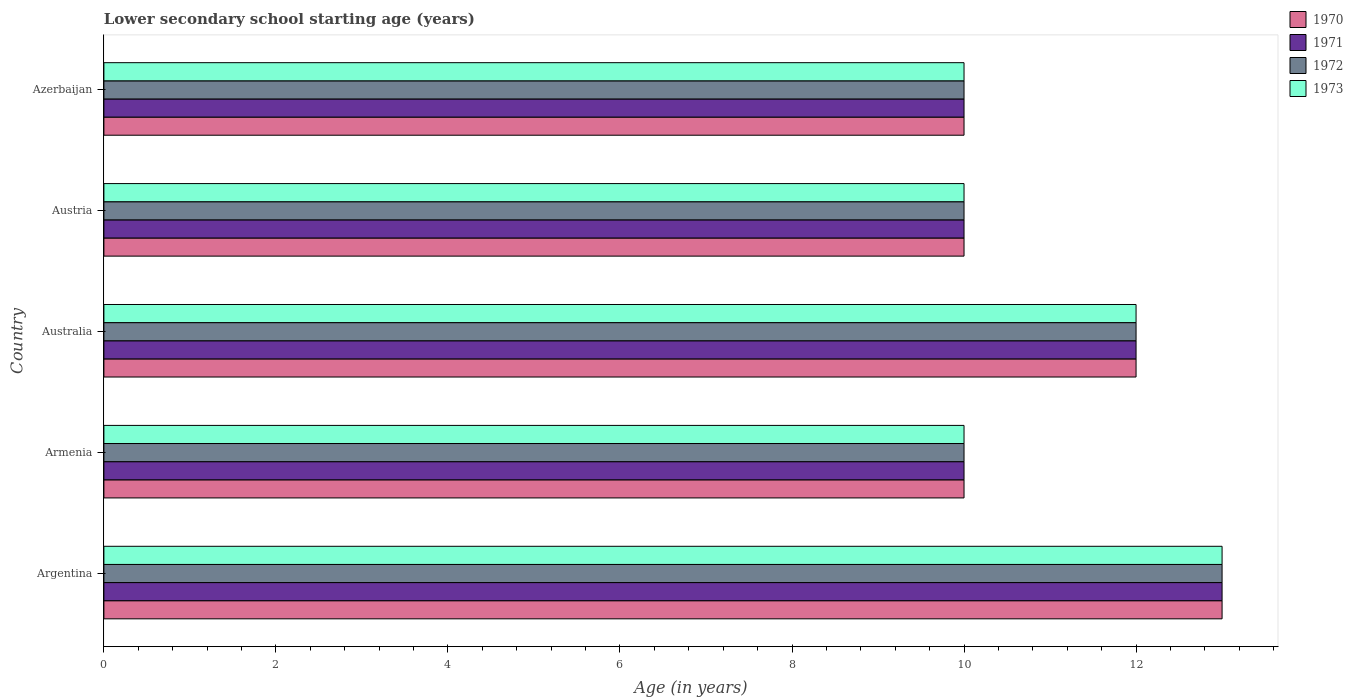How many bars are there on the 3rd tick from the top?
Your answer should be very brief. 4. How many bars are there on the 2nd tick from the bottom?
Offer a terse response. 4. What is the label of the 1st group of bars from the top?
Give a very brief answer. Azerbaijan. In how many cases, is the number of bars for a given country not equal to the number of legend labels?
Provide a short and direct response. 0. Across all countries, what is the maximum lower secondary school starting age of children in 1971?
Provide a succinct answer. 13. Across all countries, what is the minimum lower secondary school starting age of children in 1973?
Your answer should be compact. 10. In which country was the lower secondary school starting age of children in 1972 maximum?
Your answer should be compact. Argentina. In which country was the lower secondary school starting age of children in 1971 minimum?
Your answer should be compact. Armenia. What is the total lower secondary school starting age of children in 1970 in the graph?
Your response must be concise. 55. What is the difference between the lower secondary school starting age of children in 1971 in Argentina and that in Azerbaijan?
Offer a terse response. 3. What is the average lower secondary school starting age of children in 1970 per country?
Provide a succinct answer. 11. Is the lower secondary school starting age of children in 1970 in Argentina less than that in Armenia?
Provide a short and direct response. No. Is the difference between the lower secondary school starting age of children in 1973 in Armenia and Azerbaijan greater than the difference between the lower secondary school starting age of children in 1970 in Armenia and Azerbaijan?
Ensure brevity in your answer.  No. What is the difference between the highest and the second highest lower secondary school starting age of children in 1973?
Keep it short and to the point. 1. What is the difference between the highest and the lowest lower secondary school starting age of children in 1972?
Your response must be concise. 3. Is the sum of the lower secondary school starting age of children in 1971 in Armenia and Austria greater than the maximum lower secondary school starting age of children in 1972 across all countries?
Give a very brief answer. Yes. Is it the case that in every country, the sum of the lower secondary school starting age of children in 1972 and lower secondary school starting age of children in 1973 is greater than the sum of lower secondary school starting age of children in 1971 and lower secondary school starting age of children in 1970?
Your response must be concise. No. What does the 3rd bar from the top in Austria represents?
Keep it short and to the point. 1971. How many bars are there?
Your response must be concise. 20. Are all the bars in the graph horizontal?
Offer a terse response. Yes. How many countries are there in the graph?
Keep it short and to the point. 5. Where does the legend appear in the graph?
Provide a short and direct response. Top right. What is the title of the graph?
Your answer should be very brief. Lower secondary school starting age (years). What is the label or title of the X-axis?
Give a very brief answer. Age (in years). What is the Age (in years) in 1973 in Argentina?
Offer a terse response. 13. What is the Age (in years) of 1972 in Australia?
Your response must be concise. 12. What is the Age (in years) of 1970 in Austria?
Your answer should be very brief. 10. What is the Age (in years) in 1971 in Austria?
Provide a succinct answer. 10. What is the Age (in years) in 1970 in Azerbaijan?
Your answer should be compact. 10. What is the Age (in years) of 1973 in Azerbaijan?
Your answer should be very brief. 10. Across all countries, what is the maximum Age (in years) in 1971?
Your answer should be very brief. 13. Across all countries, what is the maximum Age (in years) in 1972?
Provide a succinct answer. 13. Across all countries, what is the minimum Age (in years) in 1970?
Offer a terse response. 10. What is the total Age (in years) in 1973 in the graph?
Your response must be concise. 55. What is the difference between the Age (in years) in 1971 in Argentina and that in Australia?
Ensure brevity in your answer.  1. What is the difference between the Age (in years) of 1973 in Argentina and that in Australia?
Offer a very short reply. 1. What is the difference between the Age (in years) of 1971 in Argentina and that in Austria?
Ensure brevity in your answer.  3. What is the difference between the Age (in years) in 1972 in Argentina and that in Austria?
Provide a succinct answer. 3. What is the difference between the Age (in years) of 1971 in Argentina and that in Azerbaijan?
Offer a very short reply. 3. What is the difference between the Age (in years) in 1973 in Armenia and that in Australia?
Keep it short and to the point. -2. What is the difference between the Age (in years) of 1970 in Armenia and that in Austria?
Make the answer very short. 0. What is the difference between the Age (in years) in 1971 in Armenia and that in Austria?
Offer a terse response. 0. What is the difference between the Age (in years) of 1972 in Armenia and that in Austria?
Provide a succinct answer. 0. What is the difference between the Age (in years) of 1971 in Armenia and that in Azerbaijan?
Your answer should be very brief. 0. What is the difference between the Age (in years) in 1972 in Armenia and that in Azerbaijan?
Make the answer very short. 0. What is the difference between the Age (in years) in 1973 in Armenia and that in Azerbaijan?
Keep it short and to the point. 0. What is the difference between the Age (in years) in 1971 in Australia and that in Austria?
Offer a very short reply. 2. What is the difference between the Age (in years) of 1971 in Australia and that in Azerbaijan?
Offer a terse response. 2. What is the difference between the Age (in years) in 1972 in Australia and that in Azerbaijan?
Offer a terse response. 2. What is the difference between the Age (in years) of 1970 in Austria and that in Azerbaijan?
Keep it short and to the point. 0. What is the difference between the Age (in years) in 1971 in Austria and that in Azerbaijan?
Your response must be concise. 0. What is the difference between the Age (in years) in 1972 in Austria and that in Azerbaijan?
Your answer should be very brief. 0. What is the difference between the Age (in years) of 1970 in Argentina and the Age (in years) of 1972 in Armenia?
Offer a terse response. 3. What is the difference between the Age (in years) of 1971 in Argentina and the Age (in years) of 1972 in Armenia?
Offer a terse response. 3. What is the difference between the Age (in years) in 1971 in Argentina and the Age (in years) in 1973 in Armenia?
Give a very brief answer. 3. What is the difference between the Age (in years) of 1970 in Argentina and the Age (in years) of 1971 in Australia?
Keep it short and to the point. 1. What is the difference between the Age (in years) in 1970 in Argentina and the Age (in years) in 1972 in Australia?
Your answer should be very brief. 1. What is the difference between the Age (in years) in 1970 in Argentina and the Age (in years) in 1973 in Australia?
Keep it short and to the point. 1. What is the difference between the Age (in years) of 1971 in Argentina and the Age (in years) of 1972 in Australia?
Ensure brevity in your answer.  1. What is the difference between the Age (in years) of 1972 in Argentina and the Age (in years) of 1973 in Australia?
Your answer should be compact. 1. What is the difference between the Age (in years) in 1970 in Argentina and the Age (in years) in 1972 in Austria?
Keep it short and to the point. 3. What is the difference between the Age (in years) in 1970 in Argentina and the Age (in years) in 1973 in Austria?
Provide a succinct answer. 3. What is the difference between the Age (in years) in 1970 in Argentina and the Age (in years) in 1971 in Azerbaijan?
Your answer should be very brief. 3. What is the difference between the Age (in years) in 1970 in Argentina and the Age (in years) in 1972 in Azerbaijan?
Keep it short and to the point. 3. What is the difference between the Age (in years) of 1970 in Argentina and the Age (in years) of 1973 in Azerbaijan?
Provide a succinct answer. 3. What is the difference between the Age (in years) in 1971 in Argentina and the Age (in years) in 1972 in Azerbaijan?
Your response must be concise. 3. What is the difference between the Age (in years) of 1970 in Armenia and the Age (in years) of 1971 in Australia?
Offer a terse response. -2. What is the difference between the Age (in years) of 1970 in Armenia and the Age (in years) of 1973 in Australia?
Offer a very short reply. -2. What is the difference between the Age (in years) of 1971 in Armenia and the Age (in years) of 1972 in Australia?
Provide a succinct answer. -2. What is the difference between the Age (in years) of 1971 in Armenia and the Age (in years) of 1973 in Australia?
Provide a succinct answer. -2. What is the difference between the Age (in years) of 1972 in Armenia and the Age (in years) of 1973 in Australia?
Provide a short and direct response. -2. What is the difference between the Age (in years) in 1970 in Armenia and the Age (in years) in 1971 in Austria?
Offer a terse response. 0. What is the difference between the Age (in years) in 1970 in Armenia and the Age (in years) in 1973 in Austria?
Your answer should be very brief. 0. What is the difference between the Age (in years) in 1971 in Armenia and the Age (in years) in 1972 in Azerbaijan?
Ensure brevity in your answer.  0. What is the difference between the Age (in years) of 1971 in Armenia and the Age (in years) of 1973 in Azerbaijan?
Your answer should be compact. 0. What is the difference between the Age (in years) of 1972 in Armenia and the Age (in years) of 1973 in Azerbaijan?
Keep it short and to the point. 0. What is the difference between the Age (in years) in 1972 in Australia and the Age (in years) in 1973 in Austria?
Ensure brevity in your answer.  2. What is the difference between the Age (in years) in 1970 in Australia and the Age (in years) in 1973 in Azerbaijan?
Give a very brief answer. 2. What is the difference between the Age (in years) in 1972 in Australia and the Age (in years) in 1973 in Azerbaijan?
Ensure brevity in your answer.  2. What is the difference between the Age (in years) in 1970 in Austria and the Age (in years) in 1972 in Azerbaijan?
Your answer should be very brief. 0. What is the difference between the Age (in years) of 1970 in Austria and the Age (in years) of 1973 in Azerbaijan?
Make the answer very short. 0. What is the difference between the Age (in years) of 1971 in Austria and the Age (in years) of 1972 in Azerbaijan?
Give a very brief answer. 0. What is the difference between the Age (in years) of 1971 in Austria and the Age (in years) of 1973 in Azerbaijan?
Offer a very short reply. 0. What is the difference between the Age (in years) of 1972 in Austria and the Age (in years) of 1973 in Azerbaijan?
Give a very brief answer. 0. What is the difference between the Age (in years) of 1970 and Age (in years) of 1973 in Argentina?
Your answer should be very brief. 0. What is the difference between the Age (in years) of 1971 and Age (in years) of 1973 in Argentina?
Offer a very short reply. 0. What is the difference between the Age (in years) in 1972 and Age (in years) in 1973 in Argentina?
Make the answer very short. 0. What is the difference between the Age (in years) in 1970 and Age (in years) in 1972 in Armenia?
Offer a very short reply. 0. What is the difference between the Age (in years) in 1971 and Age (in years) in 1972 in Armenia?
Keep it short and to the point. 0. What is the difference between the Age (in years) in 1970 and Age (in years) in 1972 in Australia?
Your answer should be compact. 0. What is the difference between the Age (in years) of 1971 and Age (in years) of 1972 in Australia?
Ensure brevity in your answer.  0. What is the difference between the Age (in years) in 1971 and Age (in years) in 1973 in Australia?
Your answer should be very brief. 0. What is the difference between the Age (in years) of 1971 and Age (in years) of 1973 in Austria?
Make the answer very short. 0. What is the difference between the Age (in years) of 1970 and Age (in years) of 1971 in Azerbaijan?
Make the answer very short. 0. What is the difference between the Age (in years) of 1971 and Age (in years) of 1973 in Azerbaijan?
Provide a succinct answer. 0. What is the difference between the Age (in years) in 1972 and Age (in years) in 1973 in Azerbaijan?
Your response must be concise. 0. What is the ratio of the Age (in years) in 1972 in Argentina to that in Armenia?
Make the answer very short. 1.3. What is the ratio of the Age (in years) of 1970 in Argentina to that in Australia?
Your response must be concise. 1.08. What is the ratio of the Age (in years) in 1971 in Argentina to that in Australia?
Your response must be concise. 1.08. What is the ratio of the Age (in years) in 1972 in Argentina to that in Australia?
Your answer should be compact. 1.08. What is the ratio of the Age (in years) in 1971 in Argentina to that in Austria?
Offer a very short reply. 1.3. What is the ratio of the Age (in years) of 1973 in Argentina to that in Austria?
Offer a very short reply. 1.3. What is the ratio of the Age (in years) of 1972 in Argentina to that in Azerbaijan?
Keep it short and to the point. 1.3. What is the ratio of the Age (in years) in 1973 in Argentina to that in Azerbaijan?
Make the answer very short. 1.3. What is the ratio of the Age (in years) in 1971 in Armenia to that in Australia?
Your response must be concise. 0.83. What is the ratio of the Age (in years) in 1972 in Armenia to that in Austria?
Provide a short and direct response. 1. What is the ratio of the Age (in years) of 1970 in Armenia to that in Azerbaijan?
Provide a short and direct response. 1. What is the ratio of the Age (in years) of 1973 in Armenia to that in Azerbaijan?
Offer a very short reply. 1. What is the ratio of the Age (in years) in 1973 in Australia to that in Austria?
Make the answer very short. 1.2. What is the ratio of the Age (in years) in 1973 in Australia to that in Azerbaijan?
Your answer should be compact. 1.2. What is the ratio of the Age (in years) in 1972 in Austria to that in Azerbaijan?
Offer a terse response. 1. What is the ratio of the Age (in years) of 1973 in Austria to that in Azerbaijan?
Provide a short and direct response. 1. What is the difference between the highest and the second highest Age (in years) of 1970?
Your answer should be compact. 1. What is the difference between the highest and the second highest Age (in years) of 1972?
Provide a succinct answer. 1. What is the difference between the highest and the lowest Age (in years) in 1971?
Make the answer very short. 3. What is the difference between the highest and the lowest Age (in years) in 1972?
Your response must be concise. 3. 